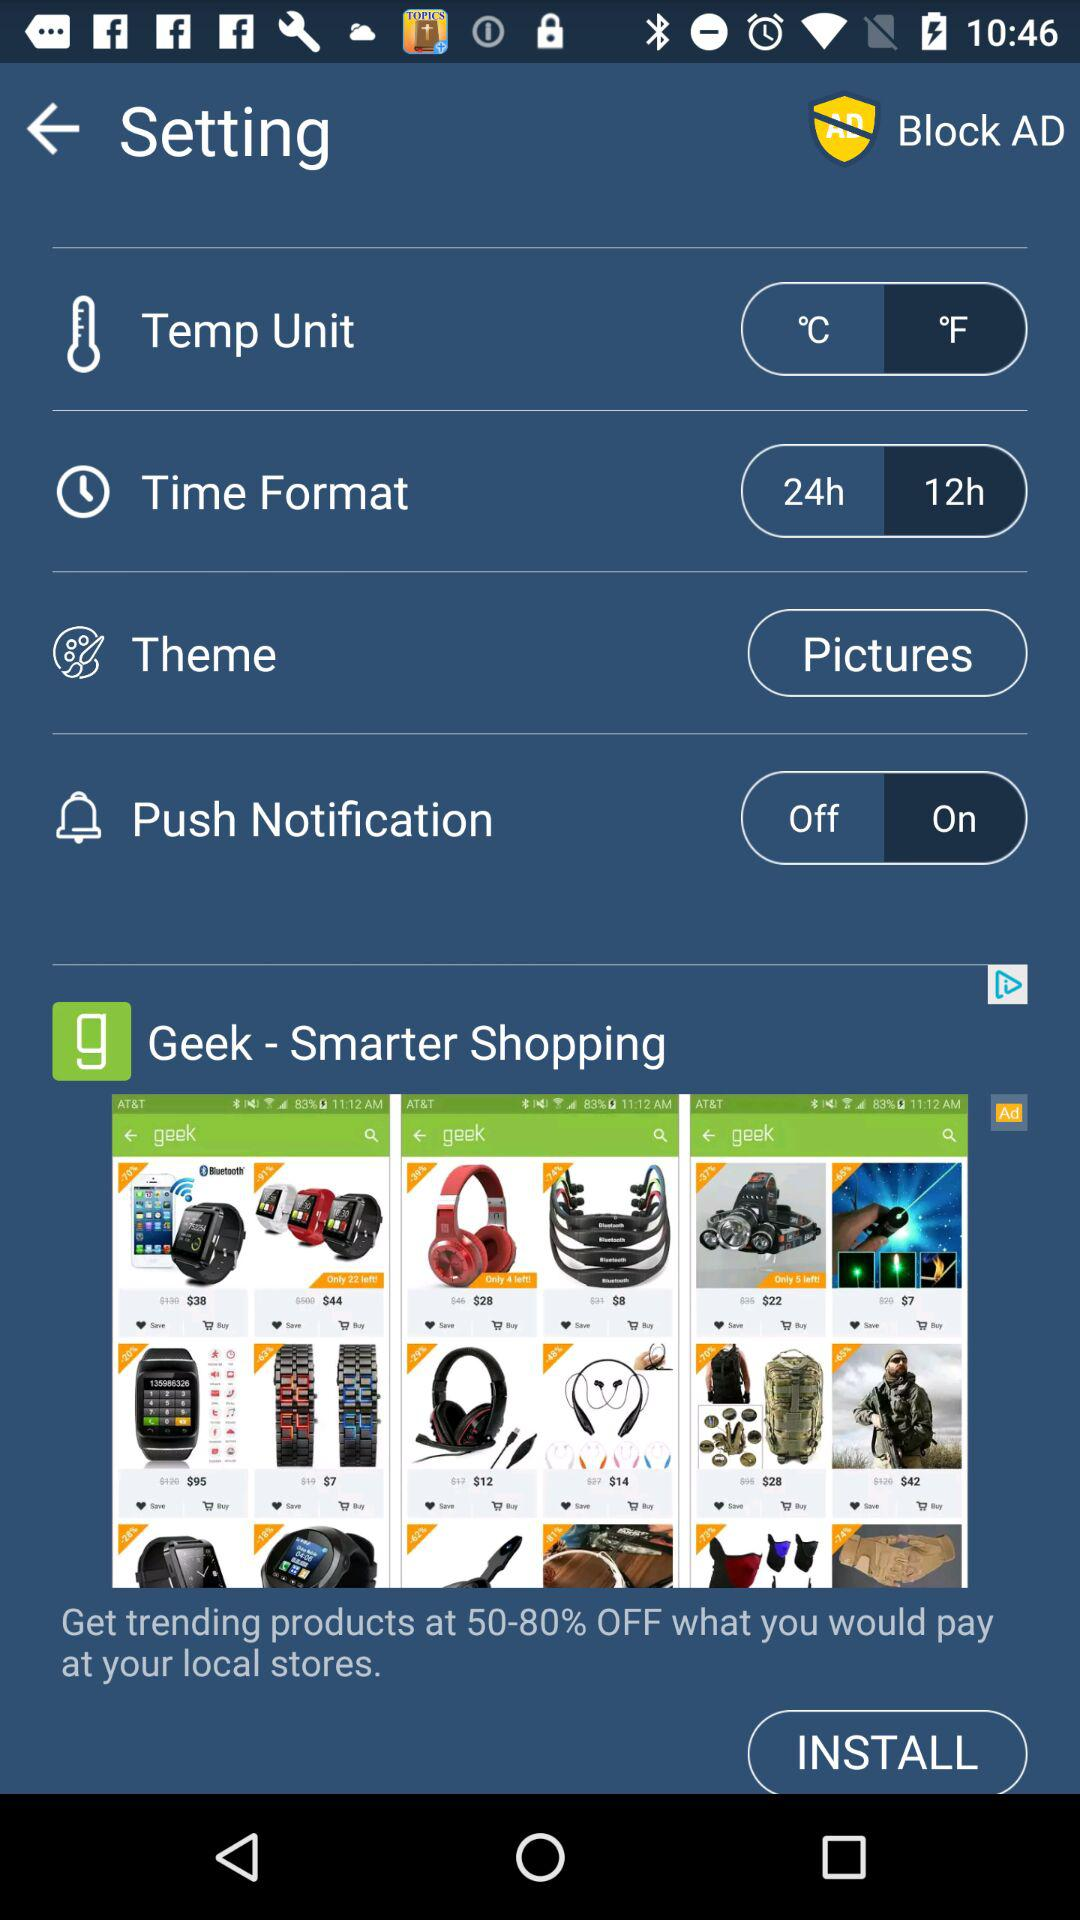What is the setting for the "Time Format"? It is 12 hours. 